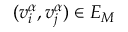<formula> <loc_0><loc_0><loc_500><loc_500>( v _ { i } ^ { \alpha } , v _ { j } ^ { \alpha } ) \in E _ { M }</formula> 